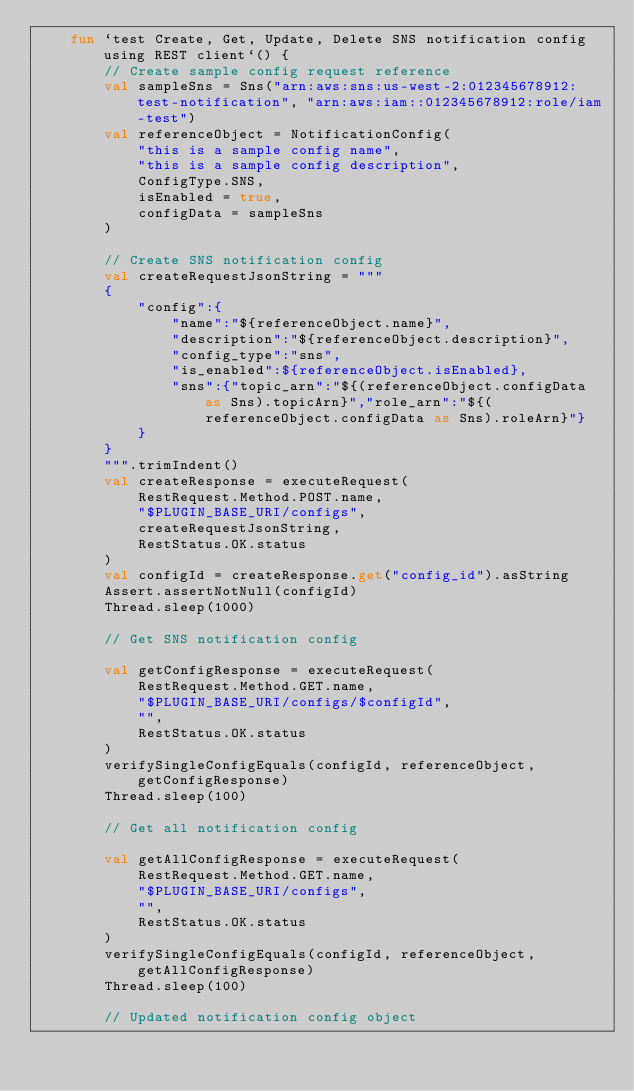<code> <loc_0><loc_0><loc_500><loc_500><_Kotlin_>    fun `test Create, Get, Update, Delete SNS notification config using REST client`() {
        // Create sample config request reference
        val sampleSns = Sns("arn:aws:sns:us-west-2:012345678912:test-notification", "arn:aws:iam::012345678912:role/iam-test")
        val referenceObject = NotificationConfig(
            "this is a sample config name",
            "this is a sample config description",
            ConfigType.SNS,
            isEnabled = true,
            configData = sampleSns
        )

        // Create SNS notification config
        val createRequestJsonString = """
        {
            "config":{
                "name":"${referenceObject.name}",
                "description":"${referenceObject.description}",
                "config_type":"sns",
                "is_enabled":${referenceObject.isEnabled},
                "sns":{"topic_arn":"${(referenceObject.configData as Sns).topicArn}","role_arn":"${(referenceObject.configData as Sns).roleArn}"}
            }
        }
        """.trimIndent()
        val createResponse = executeRequest(
            RestRequest.Method.POST.name,
            "$PLUGIN_BASE_URI/configs",
            createRequestJsonString,
            RestStatus.OK.status
        )
        val configId = createResponse.get("config_id").asString
        Assert.assertNotNull(configId)
        Thread.sleep(1000)

        // Get SNS notification config

        val getConfigResponse = executeRequest(
            RestRequest.Method.GET.name,
            "$PLUGIN_BASE_URI/configs/$configId",
            "",
            RestStatus.OK.status
        )
        verifySingleConfigEquals(configId, referenceObject, getConfigResponse)
        Thread.sleep(100)

        // Get all notification config

        val getAllConfigResponse = executeRequest(
            RestRequest.Method.GET.name,
            "$PLUGIN_BASE_URI/configs",
            "",
            RestStatus.OK.status
        )
        verifySingleConfigEquals(configId, referenceObject, getAllConfigResponse)
        Thread.sleep(100)

        // Updated notification config object</code> 